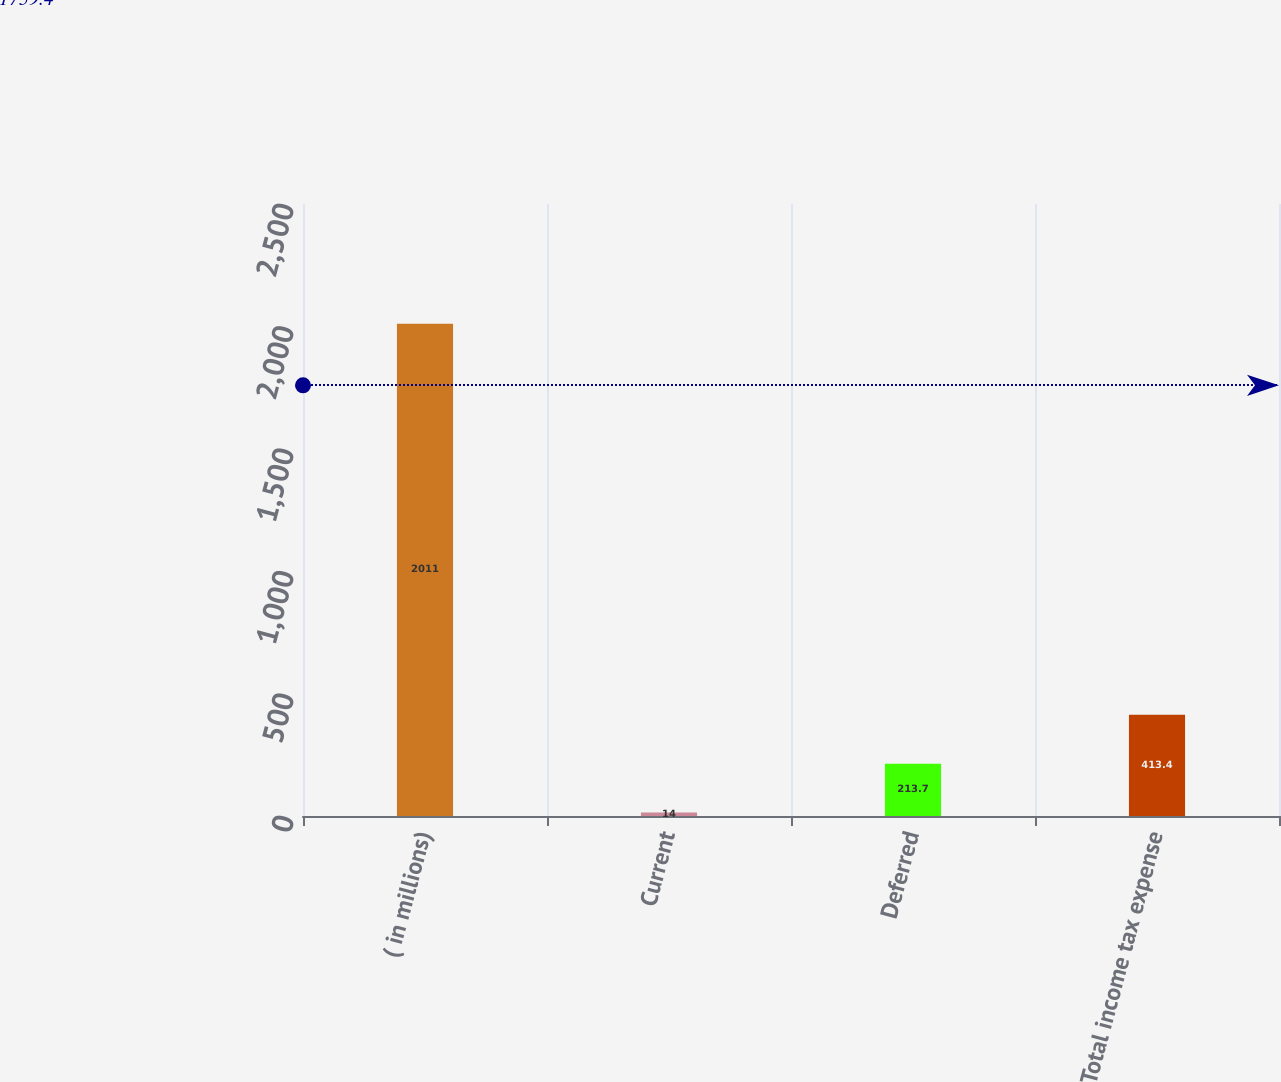Convert chart to OTSL. <chart><loc_0><loc_0><loc_500><loc_500><bar_chart><fcel>( in millions)<fcel>Current<fcel>Deferred<fcel>Total income tax expense<nl><fcel>2011<fcel>14<fcel>213.7<fcel>413.4<nl></chart> 